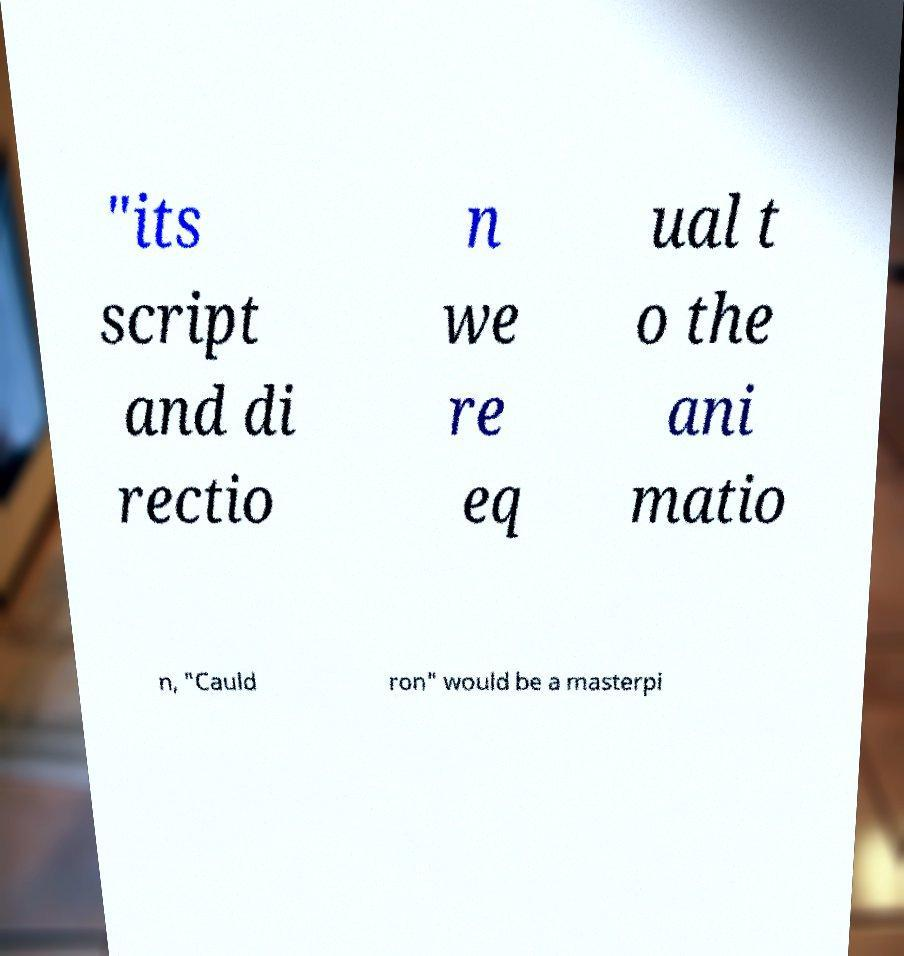What messages or text are displayed in this image? I need them in a readable, typed format. "its script and di rectio n we re eq ual t o the ani matio n, "Cauld ron" would be a masterpi 